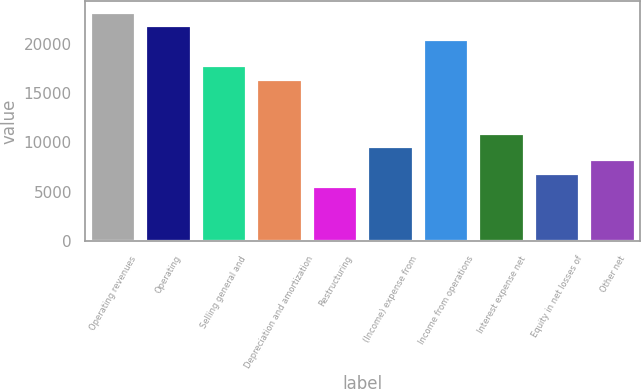Convert chart to OTSL. <chart><loc_0><loc_0><loc_500><loc_500><bar_chart><fcel>Operating revenues<fcel>Operating<fcel>Selling general and<fcel>Depreciation and amortization<fcel>Restructuring<fcel>(Income) expense from<fcel>Income from operations<fcel>Interest expense net<fcel>Equity in net losses of<fcel>Other net<nl><fcel>23134.2<fcel>21773.5<fcel>17691.3<fcel>16330.5<fcel>5444.6<fcel>9526.82<fcel>20412.7<fcel>10887.6<fcel>6805.34<fcel>8166.08<nl></chart> 